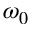<formula> <loc_0><loc_0><loc_500><loc_500>\omega _ { 0 }</formula> 